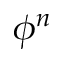<formula> <loc_0><loc_0><loc_500><loc_500>\phi ^ { n }</formula> 